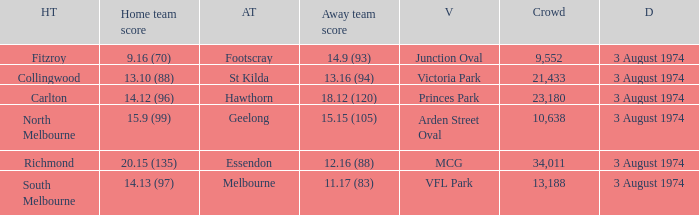Which Venue has a Home team score of 9.16 (70)? Junction Oval. Can you give me this table as a dict? {'header': ['HT', 'Home team score', 'AT', 'Away team score', 'V', 'Crowd', 'D'], 'rows': [['Fitzroy', '9.16 (70)', 'Footscray', '14.9 (93)', 'Junction Oval', '9,552', '3 August 1974'], ['Collingwood', '13.10 (88)', 'St Kilda', '13.16 (94)', 'Victoria Park', '21,433', '3 August 1974'], ['Carlton', '14.12 (96)', 'Hawthorn', '18.12 (120)', 'Princes Park', '23,180', '3 August 1974'], ['North Melbourne', '15.9 (99)', 'Geelong', '15.15 (105)', 'Arden Street Oval', '10,638', '3 August 1974'], ['Richmond', '20.15 (135)', 'Essendon', '12.16 (88)', 'MCG', '34,011', '3 August 1974'], ['South Melbourne', '14.13 (97)', 'Melbourne', '11.17 (83)', 'VFL Park', '13,188', '3 August 1974']]} 